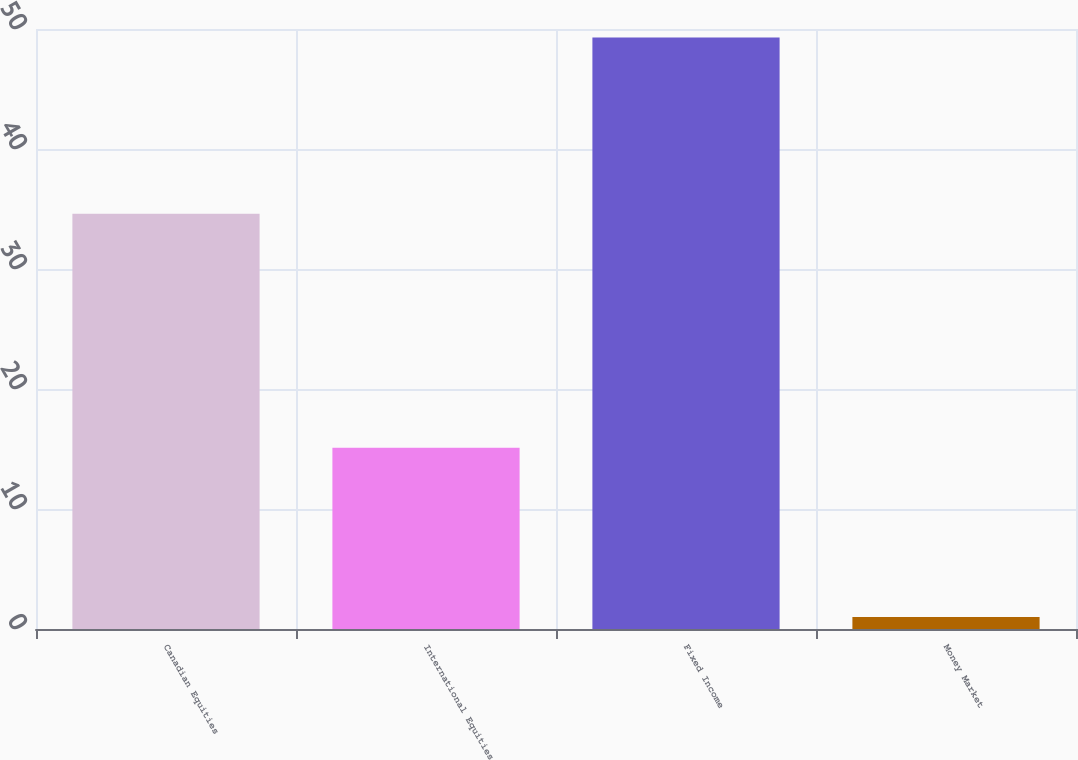Convert chart. <chart><loc_0><loc_0><loc_500><loc_500><bar_chart><fcel>Canadian Equities<fcel>International Equities<fcel>Fixed Income<fcel>Money Market<nl><fcel>34.6<fcel>15.1<fcel>49.3<fcel>1<nl></chart> 